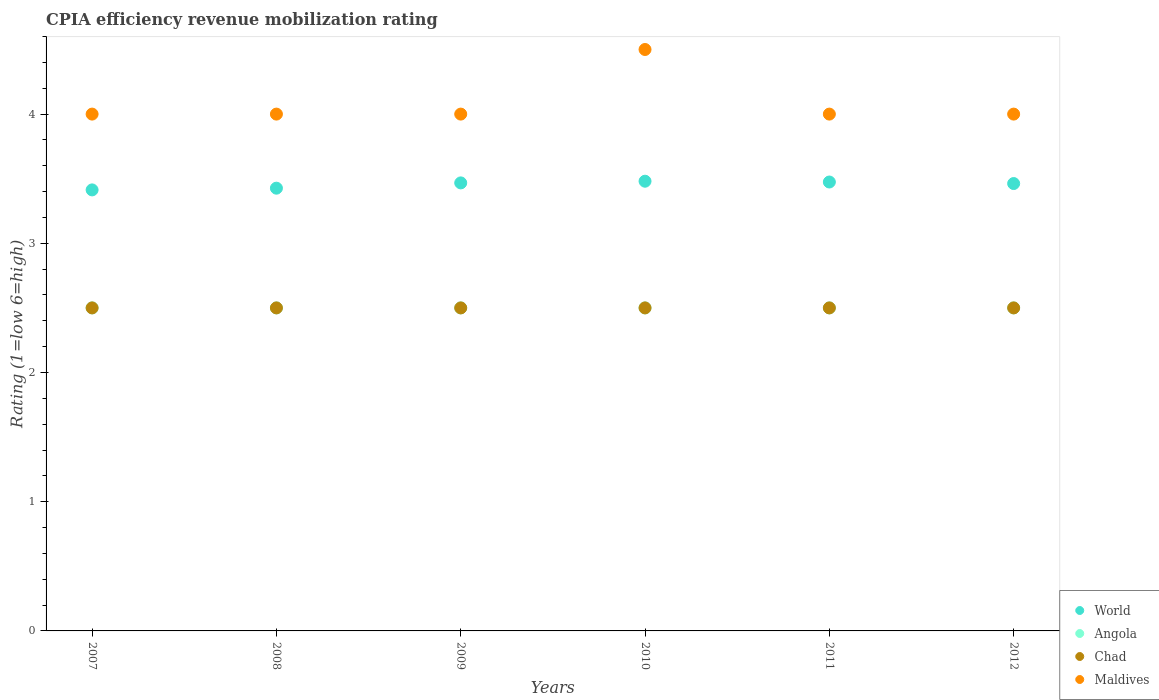How many different coloured dotlines are there?
Make the answer very short. 4. Is the number of dotlines equal to the number of legend labels?
Ensure brevity in your answer.  Yes. What is the CPIA rating in Chad in 2007?
Your response must be concise. 2.5. In which year was the CPIA rating in Chad maximum?
Keep it short and to the point. 2007. In which year was the CPIA rating in World minimum?
Give a very brief answer. 2007. What is the total CPIA rating in Chad in the graph?
Offer a terse response. 15. What is the difference between the CPIA rating in Chad in 2010 and that in 2011?
Provide a short and direct response. 0. What is the difference between the CPIA rating in Chad in 2009 and the CPIA rating in World in 2007?
Offer a very short reply. -0.91. What is the average CPIA rating in World per year?
Keep it short and to the point. 3.45. In the year 2010, what is the difference between the CPIA rating in Angola and CPIA rating in Maldives?
Give a very brief answer. -2. In how many years, is the CPIA rating in World greater than 3.6?
Offer a terse response. 0. What is the ratio of the CPIA rating in Chad in 2009 to that in 2012?
Offer a very short reply. 1. Is the difference between the CPIA rating in Angola in 2010 and 2012 greater than the difference between the CPIA rating in Maldives in 2010 and 2012?
Ensure brevity in your answer.  No. What is the difference between the highest and the second highest CPIA rating in World?
Ensure brevity in your answer.  0.01. What is the difference between the highest and the lowest CPIA rating in World?
Offer a very short reply. 0.07. Is the sum of the CPIA rating in World in 2007 and 2010 greater than the maximum CPIA rating in Angola across all years?
Provide a succinct answer. Yes. Is it the case that in every year, the sum of the CPIA rating in World and CPIA rating in Chad  is greater than the sum of CPIA rating in Maldives and CPIA rating in Angola?
Provide a short and direct response. No. Is the CPIA rating in Chad strictly less than the CPIA rating in World over the years?
Offer a terse response. Yes. How many dotlines are there?
Your response must be concise. 4. What is the difference between two consecutive major ticks on the Y-axis?
Your answer should be very brief. 1. Does the graph contain any zero values?
Ensure brevity in your answer.  No. Does the graph contain grids?
Your answer should be compact. No. Where does the legend appear in the graph?
Ensure brevity in your answer.  Bottom right. How many legend labels are there?
Offer a terse response. 4. How are the legend labels stacked?
Make the answer very short. Vertical. What is the title of the graph?
Your response must be concise. CPIA efficiency revenue mobilization rating. Does "Bahamas" appear as one of the legend labels in the graph?
Provide a succinct answer. No. What is the label or title of the X-axis?
Keep it short and to the point. Years. What is the Rating (1=low 6=high) of World in 2007?
Your answer should be very brief. 3.41. What is the Rating (1=low 6=high) of Chad in 2007?
Your answer should be very brief. 2.5. What is the Rating (1=low 6=high) in World in 2008?
Offer a very short reply. 3.43. What is the Rating (1=low 6=high) of Chad in 2008?
Ensure brevity in your answer.  2.5. What is the Rating (1=low 6=high) of World in 2009?
Keep it short and to the point. 3.47. What is the Rating (1=low 6=high) in Angola in 2009?
Offer a terse response. 2.5. What is the Rating (1=low 6=high) of World in 2010?
Your answer should be very brief. 3.48. What is the Rating (1=low 6=high) in Angola in 2010?
Your answer should be compact. 2.5. What is the Rating (1=low 6=high) in Maldives in 2010?
Give a very brief answer. 4.5. What is the Rating (1=low 6=high) in World in 2011?
Your answer should be very brief. 3.47. What is the Rating (1=low 6=high) in Angola in 2011?
Offer a very short reply. 2.5. What is the Rating (1=low 6=high) in World in 2012?
Provide a succinct answer. 3.46. Across all years, what is the maximum Rating (1=low 6=high) of World?
Provide a short and direct response. 3.48. Across all years, what is the maximum Rating (1=low 6=high) of Angola?
Your answer should be compact. 2.5. Across all years, what is the maximum Rating (1=low 6=high) of Maldives?
Offer a very short reply. 4.5. Across all years, what is the minimum Rating (1=low 6=high) in World?
Ensure brevity in your answer.  3.41. Across all years, what is the minimum Rating (1=low 6=high) in Maldives?
Provide a short and direct response. 4. What is the total Rating (1=low 6=high) in World in the graph?
Make the answer very short. 20.72. What is the total Rating (1=low 6=high) of Chad in the graph?
Your response must be concise. 15. What is the difference between the Rating (1=low 6=high) in World in 2007 and that in 2008?
Offer a very short reply. -0.01. What is the difference between the Rating (1=low 6=high) in Angola in 2007 and that in 2008?
Make the answer very short. 0. What is the difference between the Rating (1=low 6=high) in Chad in 2007 and that in 2008?
Keep it short and to the point. 0. What is the difference between the Rating (1=low 6=high) in World in 2007 and that in 2009?
Offer a very short reply. -0.05. What is the difference between the Rating (1=low 6=high) of Chad in 2007 and that in 2009?
Make the answer very short. 0. What is the difference between the Rating (1=low 6=high) of World in 2007 and that in 2010?
Provide a succinct answer. -0.07. What is the difference between the Rating (1=low 6=high) of World in 2007 and that in 2011?
Your answer should be compact. -0.06. What is the difference between the Rating (1=low 6=high) of Angola in 2007 and that in 2011?
Provide a succinct answer. 0. What is the difference between the Rating (1=low 6=high) of Chad in 2007 and that in 2011?
Provide a short and direct response. 0. What is the difference between the Rating (1=low 6=high) in Maldives in 2007 and that in 2011?
Your response must be concise. 0. What is the difference between the Rating (1=low 6=high) of World in 2007 and that in 2012?
Make the answer very short. -0.05. What is the difference between the Rating (1=low 6=high) in Chad in 2007 and that in 2012?
Ensure brevity in your answer.  0. What is the difference between the Rating (1=low 6=high) of World in 2008 and that in 2009?
Offer a terse response. -0.04. What is the difference between the Rating (1=low 6=high) of Chad in 2008 and that in 2009?
Your response must be concise. 0. What is the difference between the Rating (1=low 6=high) in World in 2008 and that in 2010?
Offer a very short reply. -0.05. What is the difference between the Rating (1=low 6=high) in Angola in 2008 and that in 2010?
Ensure brevity in your answer.  0. What is the difference between the Rating (1=low 6=high) in Chad in 2008 and that in 2010?
Your response must be concise. 0. What is the difference between the Rating (1=low 6=high) in World in 2008 and that in 2011?
Offer a terse response. -0.05. What is the difference between the Rating (1=low 6=high) of Chad in 2008 and that in 2011?
Offer a very short reply. 0. What is the difference between the Rating (1=low 6=high) of Maldives in 2008 and that in 2011?
Offer a terse response. 0. What is the difference between the Rating (1=low 6=high) in World in 2008 and that in 2012?
Offer a terse response. -0.04. What is the difference between the Rating (1=low 6=high) in Angola in 2008 and that in 2012?
Offer a very short reply. 0. What is the difference between the Rating (1=low 6=high) of Chad in 2008 and that in 2012?
Offer a terse response. 0. What is the difference between the Rating (1=low 6=high) in Maldives in 2008 and that in 2012?
Your answer should be very brief. 0. What is the difference between the Rating (1=low 6=high) of World in 2009 and that in 2010?
Give a very brief answer. -0.01. What is the difference between the Rating (1=low 6=high) in Angola in 2009 and that in 2010?
Your answer should be very brief. 0. What is the difference between the Rating (1=low 6=high) of World in 2009 and that in 2011?
Your answer should be compact. -0.01. What is the difference between the Rating (1=low 6=high) of Angola in 2009 and that in 2011?
Offer a terse response. 0. What is the difference between the Rating (1=low 6=high) of World in 2009 and that in 2012?
Provide a short and direct response. 0.01. What is the difference between the Rating (1=low 6=high) in Angola in 2009 and that in 2012?
Your answer should be very brief. 0. What is the difference between the Rating (1=low 6=high) of Maldives in 2009 and that in 2012?
Provide a short and direct response. 0. What is the difference between the Rating (1=low 6=high) in World in 2010 and that in 2011?
Provide a short and direct response. 0.01. What is the difference between the Rating (1=low 6=high) of Angola in 2010 and that in 2011?
Your answer should be very brief. 0. What is the difference between the Rating (1=low 6=high) in Chad in 2010 and that in 2011?
Your answer should be very brief. 0. What is the difference between the Rating (1=low 6=high) of Maldives in 2010 and that in 2011?
Ensure brevity in your answer.  0.5. What is the difference between the Rating (1=low 6=high) of World in 2010 and that in 2012?
Offer a very short reply. 0.02. What is the difference between the Rating (1=low 6=high) in World in 2011 and that in 2012?
Your answer should be compact. 0.01. What is the difference between the Rating (1=low 6=high) of World in 2007 and the Rating (1=low 6=high) of Angola in 2008?
Provide a short and direct response. 0.91. What is the difference between the Rating (1=low 6=high) of World in 2007 and the Rating (1=low 6=high) of Chad in 2008?
Your answer should be compact. 0.91. What is the difference between the Rating (1=low 6=high) in World in 2007 and the Rating (1=low 6=high) in Maldives in 2008?
Your answer should be very brief. -0.59. What is the difference between the Rating (1=low 6=high) in World in 2007 and the Rating (1=low 6=high) in Angola in 2009?
Offer a terse response. 0.91. What is the difference between the Rating (1=low 6=high) in World in 2007 and the Rating (1=low 6=high) in Chad in 2009?
Make the answer very short. 0.91. What is the difference between the Rating (1=low 6=high) of World in 2007 and the Rating (1=low 6=high) of Maldives in 2009?
Ensure brevity in your answer.  -0.59. What is the difference between the Rating (1=low 6=high) of Angola in 2007 and the Rating (1=low 6=high) of Chad in 2009?
Your response must be concise. 0. What is the difference between the Rating (1=low 6=high) in World in 2007 and the Rating (1=low 6=high) in Angola in 2010?
Ensure brevity in your answer.  0.91. What is the difference between the Rating (1=low 6=high) in World in 2007 and the Rating (1=low 6=high) in Chad in 2010?
Ensure brevity in your answer.  0.91. What is the difference between the Rating (1=low 6=high) of World in 2007 and the Rating (1=low 6=high) of Maldives in 2010?
Provide a succinct answer. -1.09. What is the difference between the Rating (1=low 6=high) of Chad in 2007 and the Rating (1=low 6=high) of Maldives in 2010?
Provide a short and direct response. -2. What is the difference between the Rating (1=low 6=high) of World in 2007 and the Rating (1=low 6=high) of Angola in 2011?
Your answer should be compact. 0.91. What is the difference between the Rating (1=low 6=high) in World in 2007 and the Rating (1=low 6=high) in Chad in 2011?
Provide a succinct answer. 0.91. What is the difference between the Rating (1=low 6=high) in World in 2007 and the Rating (1=low 6=high) in Maldives in 2011?
Give a very brief answer. -0.59. What is the difference between the Rating (1=low 6=high) of Angola in 2007 and the Rating (1=low 6=high) of Chad in 2011?
Offer a terse response. 0. What is the difference between the Rating (1=low 6=high) of Chad in 2007 and the Rating (1=low 6=high) of Maldives in 2011?
Make the answer very short. -1.5. What is the difference between the Rating (1=low 6=high) of World in 2007 and the Rating (1=low 6=high) of Angola in 2012?
Keep it short and to the point. 0.91. What is the difference between the Rating (1=low 6=high) in World in 2007 and the Rating (1=low 6=high) in Chad in 2012?
Your response must be concise. 0.91. What is the difference between the Rating (1=low 6=high) in World in 2007 and the Rating (1=low 6=high) in Maldives in 2012?
Offer a very short reply. -0.59. What is the difference between the Rating (1=low 6=high) in Angola in 2007 and the Rating (1=low 6=high) in Chad in 2012?
Provide a succinct answer. 0. What is the difference between the Rating (1=low 6=high) in Angola in 2007 and the Rating (1=low 6=high) in Maldives in 2012?
Ensure brevity in your answer.  -1.5. What is the difference between the Rating (1=low 6=high) of Chad in 2007 and the Rating (1=low 6=high) of Maldives in 2012?
Your answer should be compact. -1.5. What is the difference between the Rating (1=low 6=high) in World in 2008 and the Rating (1=low 6=high) in Angola in 2009?
Provide a short and direct response. 0.93. What is the difference between the Rating (1=low 6=high) of World in 2008 and the Rating (1=low 6=high) of Chad in 2009?
Your response must be concise. 0.93. What is the difference between the Rating (1=low 6=high) of World in 2008 and the Rating (1=low 6=high) of Maldives in 2009?
Make the answer very short. -0.57. What is the difference between the Rating (1=low 6=high) of Angola in 2008 and the Rating (1=low 6=high) of Chad in 2009?
Your answer should be compact. 0. What is the difference between the Rating (1=low 6=high) in World in 2008 and the Rating (1=low 6=high) in Angola in 2010?
Keep it short and to the point. 0.93. What is the difference between the Rating (1=low 6=high) in World in 2008 and the Rating (1=low 6=high) in Chad in 2010?
Your answer should be very brief. 0.93. What is the difference between the Rating (1=low 6=high) in World in 2008 and the Rating (1=low 6=high) in Maldives in 2010?
Give a very brief answer. -1.07. What is the difference between the Rating (1=low 6=high) of Angola in 2008 and the Rating (1=low 6=high) of Maldives in 2010?
Offer a very short reply. -2. What is the difference between the Rating (1=low 6=high) of Chad in 2008 and the Rating (1=low 6=high) of Maldives in 2010?
Your response must be concise. -2. What is the difference between the Rating (1=low 6=high) in World in 2008 and the Rating (1=low 6=high) in Angola in 2011?
Offer a terse response. 0.93. What is the difference between the Rating (1=low 6=high) of World in 2008 and the Rating (1=low 6=high) of Chad in 2011?
Offer a very short reply. 0.93. What is the difference between the Rating (1=low 6=high) of World in 2008 and the Rating (1=low 6=high) of Maldives in 2011?
Ensure brevity in your answer.  -0.57. What is the difference between the Rating (1=low 6=high) of Angola in 2008 and the Rating (1=low 6=high) of Maldives in 2011?
Provide a succinct answer. -1.5. What is the difference between the Rating (1=low 6=high) of World in 2008 and the Rating (1=low 6=high) of Angola in 2012?
Provide a succinct answer. 0.93. What is the difference between the Rating (1=low 6=high) of World in 2008 and the Rating (1=low 6=high) of Chad in 2012?
Provide a succinct answer. 0.93. What is the difference between the Rating (1=low 6=high) in World in 2008 and the Rating (1=low 6=high) in Maldives in 2012?
Provide a short and direct response. -0.57. What is the difference between the Rating (1=low 6=high) of Angola in 2008 and the Rating (1=low 6=high) of Chad in 2012?
Offer a terse response. 0. What is the difference between the Rating (1=low 6=high) in Chad in 2008 and the Rating (1=low 6=high) in Maldives in 2012?
Offer a terse response. -1.5. What is the difference between the Rating (1=low 6=high) in World in 2009 and the Rating (1=low 6=high) in Angola in 2010?
Ensure brevity in your answer.  0.97. What is the difference between the Rating (1=low 6=high) of World in 2009 and the Rating (1=low 6=high) of Chad in 2010?
Your answer should be very brief. 0.97. What is the difference between the Rating (1=low 6=high) of World in 2009 and the Rating (1=low 6=high) of Maldives in 2010?
Your answer should be compact. -1.03. What is the difference between the Rating (1=low 6=high) of Angola in 2009 and the Rating (1=low 6=high) of Chad in 2010?
Make the answer very short. 0. What is the difference between the Rating (1=low 6=high) in Angola in 2009 and the Rating (1=low 6=high) in Maldives in 2010?
Your answer should be compact. -2. What is the difference between the Rating (1=low 6=high) in Chad in 2009 and the Rating (1=low 6=high) in Maldives in 2010?
Provide a short and direct response. -2. What is the difference between the Rating (1=low 6=high) of World in 2009 and the Rating (1=low 6=high) of Angola in 2011?
Keep it short and to the point. 0.97. What is the difference between the Rating (1=low 6=high) of World in 2009 and the Rating (1=low 6=high) of Chad in 2011?
Ensure brevity in your answer.  0.97. What is the difference between the Rating (1=low 6=high) of World in 2009 and the Rating (1=low 6=high) of Maldives in 2011?
Ensure brevity in your answer.  -0.53. What is the difference between the Rating (1=low 6=high) of Chad in 2009 and the Rating (1=low 6=high) of Maldives in 2011?
Make the answer very short. -1.5. What is the difference between the Rating (1=low 6=high) of World in 2009 and the Rating (1=low 6=high) of Angola in 2012?
Your answer should be compact. 0.97. What is the difference between the Rating (1=low 6=high) in World in 2009 and the Rating (1=low 6=high) in Chad in 2012?
Ensure brevity in your answer.  0.97. What is the difference between the Rating (1=low 6=high) in World in 2009 and the Rating (1=low 6=high) in Maldives in 2012?
Your answer should be compact. -0.53. What is the difference between the Rating (1=low 6=high) in Chad in 2009 and the Rating (1=low 6=high) in Maldives in 2012?
Provide a succinct answer. -1.5. What is the difference between the Rating (1=low 6=high) in World in 2010 and the Rating (1=low 6=high) in Angola in 2011?
Ensure brevity in your answer.  0.98. What is the difference between the Rating (1=low 6=high) of World in 2010 and the Rating (1=low 6=high) of Chad in 2011?
Your answer should be compact. 0.98. What is the difference between the Rating (1=low 6=high) in World in 2010 and the Rating (1=low 6=high) in Maldives in 2011?
Ensure brevity in your answer.  -0.52. What is the difference between the Rating (1=low 6=high) of Angola in 2010 and the Rating (1=low 6=high) of Maldives in 2011?
Your answer should be very brief. -1.5. What is the difference between the Rating (1=low 6=high) in Chad in 2010 and the Rating (1=low 6=high) in Maldives in 2011?
Your answer should be compact. -1.5. What is the difference between the Rating (1=low 6=high) of World in 2010 and the Rating (1=low 6=high) of Angola in 2012?
Your answer should be compact. 0.98. What is the difference between the Rating (1=low 6=high) of World in 2010 and the Rating (1=low 6=high) of Chad in 2012?
Your response must be concise. 0.98. What is the difference between the Rating (1=low 6=high) of World in 2010 and the Rating (1=low 6=high) of Maldives in 2012?
Ensure brevity in your answer.  -0.52. What is the difference between the Rating (1=low 6=high) in Angola in 2010 and the Rating (1=low 6=high) in Maldives in 2012?
Ensure brevity in your answer.  -1.5. What is the difference between the Rating (1=low 6=high) in World in 2011 and the Rating (1=low 6=high) in Angola in 2012?
Your answer should be very brief. 0.97. What is the difference between the Rating (1=low 6=high) in World in 2011 and the Rating (1=low 6=high) in Chad in 2012?
Offer a terse response. 0.97. What is the difference between the Rating (1=low 6=high) of World in 2011 and the Rating (1=low 6=high) of Maldives in 2012?
Offer a very short reply. -0.53. What is the difference between the Rating (1=low 6=high) in Angola in 2011 and the Rating (1=low 6=high) in Maldives in 2012?
Your answer should be very brief. -1.5. What is the average Rating (1=low 6=high) of World per year?
Offer a very short reply. 3.45. What is the average Rating (1=low 6=high) of Angola per year?
Offer a very short reply. 2.5. What is the average Rating (1=low 6=high) of Maldives per year?
Your response must be concise. 4.08. In the year 2007, what is the difference between the Rating (1=low 6=high) in World and Rating (1=low 6=high) in Angola?
Make the answer very short. 0.91. In the year 2007, what is the difference between the Rating (1=low 6=high) of World and Rating (1=low 6=high) of Chad?
Give a very brief answer. 0.91. In the year 2007, what is the difference between the Rating (1=low 6=high) of World and Rating (1=low 6=high) of Maldives?
Offer a terse response. -0.59. In the year 2007, what is the difference between the Rating (1=low 6=high) of Angola and Rating (1=low 6=high) of Chad?
Your answer should be compact. 0. In the year 2007, what is the difference between the Rating (1=low 6=high) of Angola and Rating (1=low 6=high) of Maldives?
Make the answer very short. -1.5. In the year 2007, what is the difference between the Rating (1=low 6=high) of Chad and Rating (1=low 6=high) of Maldives?
Offer a very short reply. -1.5. In the year 2008, what is the difference between the Rating (1=low 6=high) of World and Rating (1=low 6=high) of Angola?
Make the answer very short. 0.93. In the year 2008, what is the difference between the Rating (1=low 6=high) in World and Rating (1=low 6=high) in Chad?
Your response must be concise. 0.93. In the year 2008, what is the difference between the Rating (1=low 6=high) of World and Rating (1=low 6=high) of Maldives?
Your answer should be very brief. -0.57. In the year 2008, what is the difference between the Rating (1=low 6=high) of Angola and Rating (1=low 6=high) of Maldives?
Provide a short and direct response. -1.5. In the year 2008, what is the difference between the Rating (1=low 6=high) of Chad and Rating (1=low 6=high) of Maldives?
Offer a terse response. -1.5. In the year 2009, what is the difference between the Rating (1=low 6=high) of World and Rating (1=low 6=high) of Angola?
Make the answer very short. 0.97. In the year 2009, what is the difference between the Rating (1=low 6=high) of World and Rating (1=low 6=high) of Chad?
Your response must be concise. 0.97. In the year 2009, what is the difference between the Rating (1=low 6=high) in World and Rating (1=low 6=high) in Maldives?
Offer a very short reply. -0.53. In the year 2009, what is the difference between the Rating (1=low 6=high) in Angola and Rating (1=low 6=high) in Chad?
Offer a very short reply. 0. In the year 2009, what is the difference between the Rating (1=low 6=high) of Chad and Rating (1=low 6=high) of Maldives?
Ensure brevity in your answer.  -1.5. In the year 2010, what is the difference between the Rating (1=low 6=high) of World and Rating (1=low 6=high) of Angola?
Provide a short and direct response. 0.98. In the year 2010, what is the difference between the Rating (1=low 6=high) of World and Rating (1=low 6=high) of Chad?
Your answer should be compact. 0.98. In the year 2010, what is the difference between the Rating (1=low 6=high) in World and Rating (1=low 6=high) in Maldives?
Make the answer very short. -1.02. In the year 2010, what is the difference between the Rating (1=low 6=high) of Angola and Rating (1=low 6=high) of Maldives?
Your answer should be compact. -2. In the year 2011, what is the difference between the Rating (1=low 6=high) in World and Rating (1=low 6=high) in Angola?
Provide a succinct answer. 0.97. In the year 2011, what is the difference between the Rating (1=low 6=high) of World and Rating (1=low 6=high) of Chad?
Provide a short and direct response. 0.97. In the year 2011, what is the difference between the Rating (1=low 6=high) of World and Rating (1=low 6=high) of Maldives?
Offer a terse response. -0.53. In the year 2011, what is the difference between the Rating (1=low 6=high) of Angola and Rating (1=low 6=high) of Chad?
Ensure brevity in your answer.  0. In the year 2012, what is the difference between the Rating (1=low 6=high) in World and Rating (1=low 6=high) in Angola?
Your response must be concise. 0.96. In the year 2012, what is the difference between the Rating (1=low 6=high) of World and Rating (1=low 6=high) of Chad?
Offer a very short reply. 0.96. In the year 2012, what is the difference between the Rating (1=low 6=high) of World and Rating (1=low 6=high) of Maldives?
Ensure brevity in your answer.  -0.54. In the year 2012, what is the difference between the Rating (1=low 6=high) in Angola and Rating (1=low 6=high) in Chad?
Make the answer very short. 0. In the year 2012, what is the difference between the Rating (1=low 6=high) in Angola and Rating (1=low 6=high) in Maldives?
Give a very brief answer. -1.5. What is the ratio of the Rating (1=low 6=high) of World in 2007 to that in 2008?
Keep it short and to the point. 1. What is the ratio of the Rating (1=low 6=high) in Angola in 2007 to that in 2008?
Your answer should be compact. 1. What is the ratio of the Rating (1=low 6=high) of Chad in 2007 to that in 2008?
Provide a succinct answer. 1. What is the ratio of the Rating (1=low 6=high) in Maldives in 2007 to that in 2008?
Ensure brevity in your answer.  1. What is the ratio of the Rating (1=low 6=high) in World in 2007 to that in 2009?
Your answer should be compact. 0.98. What is the ratio of the Rating (1=low 6=high) in Angola in 2007 to that in 2009?
Your answer should be very brief. 1. What is the ratio of the Rating (1=low 6=high) of Chad in 2007 to that in 2009?
Ensure brevity in your answer.  1. What is the ratio of the Rating (1=low 6=high) of Maldives in 2007 to that in 2009?
Ensure brevity in your answer.  1. What is the ratio of the Rating (1=low 6=high) of World in 2007 to that in 2010?
Give a very brief answer. 0.98. What is the ratio of the Rating (1=low 6=high) in Chad in 2007 to that in 2010?
Provide a succinct answer. 1. What is the ratio of the Rating (1=low 6=high) in Maldives in 2007 to that in 2010?
Provide a short and direct response. 0.89. What is the ratio of the Rating (1=low 6=high) in World in 2007 to that in 2011?
Your answer should be compact. 0.98. What is the ratio of the Rating (1=low 6=high) in Angola in 2007 to that in 2011?
Offer a very short reply. 1. What is the ratio of the Rating (1=low 6=high) of World in 2007 to that in 2012?
Give a very brief answer. 0.99. What is the ratio of the Rating (1=low 6=high) in World in 2008 to that in 2009?
Offer a terse response. 0.99. What is the ratio of the Rating (1=low 6=high) of Angola in 2008 to that in 2009?
Your response must be concise. 1. What is the ratio of the Rating (1=low 6=high) in Chad in 2008 to that in 2009?
Your answer should be compact. 1. What is the ratio of the Rating (1=low 6=high) of World in 2008 to that in 2010?
Your response must be concise. 0.98. What is the ratio of the Rating (1=low 6=high) in Maldives in 2008 to that in 2010?
Offer a very short reply. 0.89. What is the ratio of the Rating (1=low 6=high) of World in 2008 to that in 2011?
Your answer should be very brief. 0.99. What is the ratio of the Rating (1=low 6=high) of World in 2008 to that in 2012?
Provide a succinct answer. 0.99. What is the ratio of the Rating (1=low 6=high) in Maldives in 2008 to that in 2012?
Make the answer very short. 1. What is the ratio of the Rating (1=low 6=high) of Angola in 2009 to that in 2010?
Your answer should be very brief. 1. What is the ratio of the Rating (1=low 6=high) in Maldives in 2009 to that in 2011?
Your answer should be compact. 1. What is the ratio of the Rating (1=low 6=high) in World in 2009 to that in 2012?
Make the answer very short. 1. What is the ratio of the Rating (1=low 6=high) of Angola in 2009 to that in 2012?
Provide a succinct answer. 1. What is the ratio of the Rating (1=low 6=high) in Maldives in 2010 to that in 2011?
Make the answer very short. 1.12. What is the ratio of the Rating (1=low 6=high) in World in 2010 to that in 2012?
Offer a terse response. 1.01. What is the ratio of the Rating (1=low 6=high) in Maldives in 2010 to that in 2012?
Your response must be concise. 1.12. What is the ratio of the Rating (1=low 6=high) of World in 2011 to that in 2012?
Make the answer very short. 1. What is the ratio of the Rating (1=low 6=high) of Chad in 2011 to that in 2012?
Make the answer very short. 1. What is the difference between the highest and the second highest Rating (1=low 6=high) in World?
Your response must be concise. 0.01. What is the difference between the highest and the lowest Rating (1=low 6=high) of World?
Make the answer very short. 0.07. What is the difference between the highest and the lowest Rating (1=low 6=high) of Chad?
Keep it short and to the point. 0. 